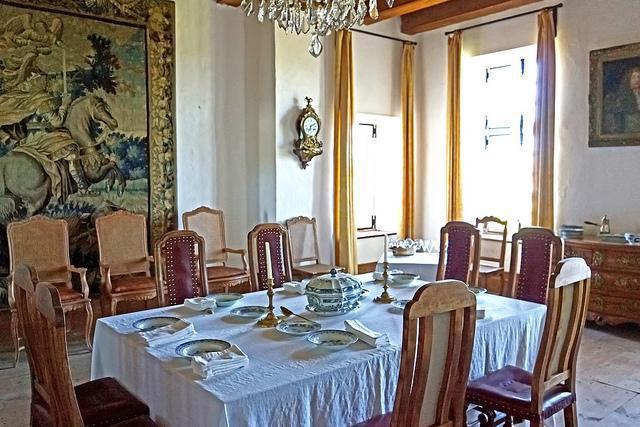How many chairs have been put into place?
Give a very brief answer. 7. How many chairs are there?
Give a very brief answer. 10. 